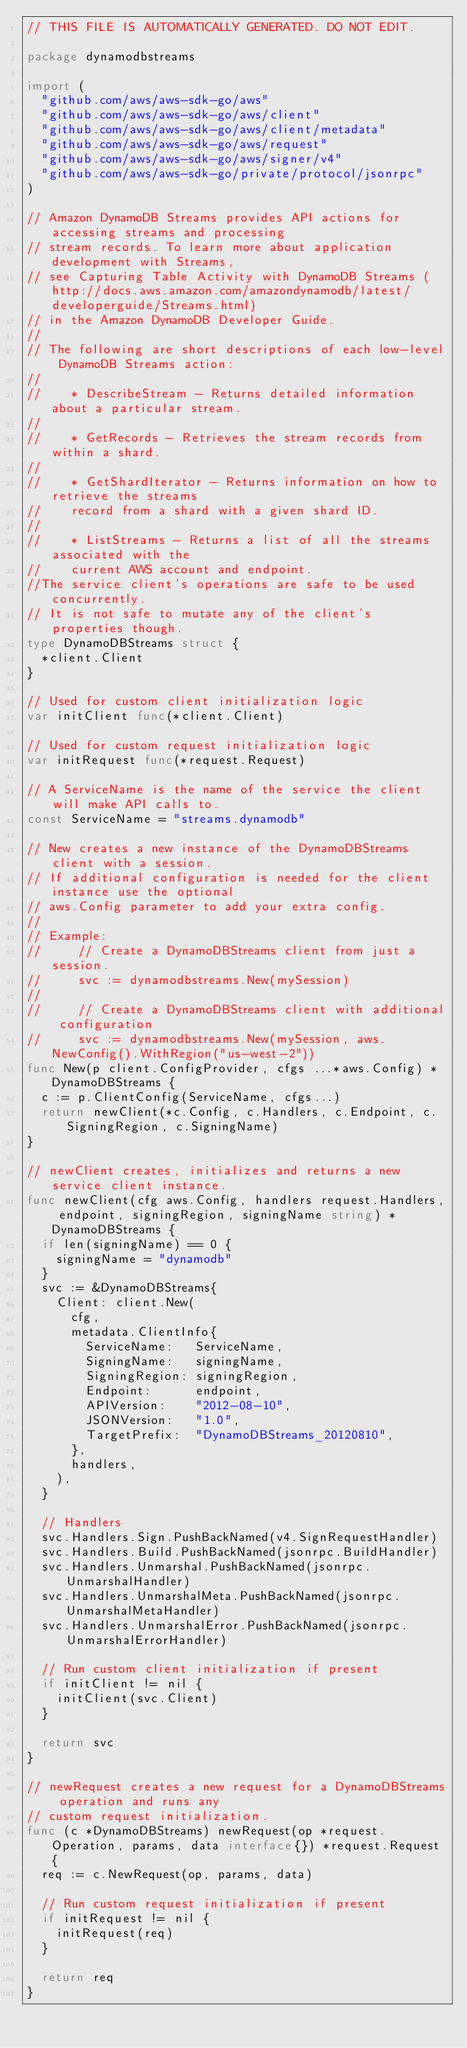<code> <loc_0><loc_0><loc_500><loc_500><_Go_>// THIS FILE IS AUTOMATICALLY GENERATED. DO NOT EDIT.

package dynamodbstreams

import (
	"github.com/aws/aws-sdk-go/aws"
	"github.com/aws/aws-sdk-go/aws/client"
	"github.com/aws/aws-sdk-go/aws/client/metadata"
	"github.com/aws/aws-sdk-go/aws/request"
	"github.com/aws/aws-sdk-go/aws/signer/v4"
	"github.com/aws/aws-sdk-go/private/protocol/jsonrpc"
)

// Amazon DynamoDB Streams provides API actions for accessing streams and processing
// stream records. To learn more about application development with Streams,
// see Capturing Table Activity with DynamoDB Streams (http://docs.aws.amazon.com/amazondynamodb/latest/developerguide/Streams.html)
// in the Amazon DynamoDB Developer Guide.
//
// The following are short descriptions of each low-level DynamoDB Streams action:
//
//    * DescribeStream - Returns detailed information about a particular stream.
//
//    * GetRecords - Retrieves the stream records from within a shard.
//
//    * GetShardIterator - Returns information on how to retrieve the streams
//    record from a shard with a given shard ID.
//
//    * ListStreams - Returns a list of all the streams associated with the
//    current AWS account and endpoint.
//The service client's operations are safe to be used concurrently.
// It is not safe to mutate any of the client's properties though.
type DynamoDBStreams struct {
	*client.Client
}

// Used for custom client initialization logic
var initClient func(*client.Client)

// Used for custom request initialization logic
var initRequest func(*request.Request)

// A ServiceName is the name of the service the client will make API calls to.
const ServiceName = "streams.dynamodb"

// New creates a new instance of the DynamoDBStreams client with a session.
// If additional configuration is needed for the client instance use the optional
// aws.Config parameter to add your extra config.
//
// Example:
//     // Create a DynamoDBStreams client from just a session.
//     svc := dynamodbstreams.New(mySession)
//
//     // Create a DynamoDBStreams client with additional configuration
//     svc := dynamodbstreams.New(mySession, aws.NewConfig().WithRegion("us-west-2"))
func New(p client.ConfigProvider, cfgs ...*aws.Config) *DynamoDBStreams {
	c := p.ClientConfig(ServiceName, cfgs...)
	return newClient(*c.Config, c.Handlers, c.Endpoint, c.SigningRegion, c.SigningName)
}

// newClient creates, initializes and returns a new service client instance.
func newClient(cfg aws.Config, handlers request.Handlers, endpoint, signingRegion, signingName string) *DynamoDBStreams {
	if len(signingName) == 0 {
		signingName = "dynamodb"
	}
	svc := &DynamoDBStreams{
		Client: client.New(
			cfg,
			metadata.ClientInfo{
				ServiceName:   ServiceName,
				SigningName:   signingName,
				SigningRegion: signingRegion,
				Endpoint:      endpoint,
				APIVersion:    "2012-08-10",
				JSONVersion:   "1.0",
				TargetPrefix:  "DynamoDBStreams_20120810",
			},
			handlers,
		),
	}

	// Handlers
	svc.Handlers.Sign.PushBackNamed(v4.SignRequestHandler)
	svc.Handlers.Build.PushBackNamed(jsonrpc.BuildHandler)
	svc.Handlers.Unmarshal.PushBackNamed(jsonrpc.UnmarshalHandler)
	svc.Handlers.UnmarshalMeta.PushBackNamed(jsonrpc.UnmarshalMetaHandler)
	svc.Handlers.UnmarshalError.PushBackNamed(jsonrpc.UnmarshalErrorHandler)

	// Run custom client initialization if present
	if initClient != nil {
		initClient(svc.Client)
	}

	return svc
}

// newRequest creates a new request for a DynamoDBStreams operation and runs any
// custom request initialization.
func (c *DynamoDBStreams) newRequest(op *request.Operation, params, data interface{}) *request.Request {
	req := c.NewRequest(op, params, data)

	// Run custom request initialization if present
	if initRequest != nil {
		initRequest(req)
	}

	return req
}
</code> 